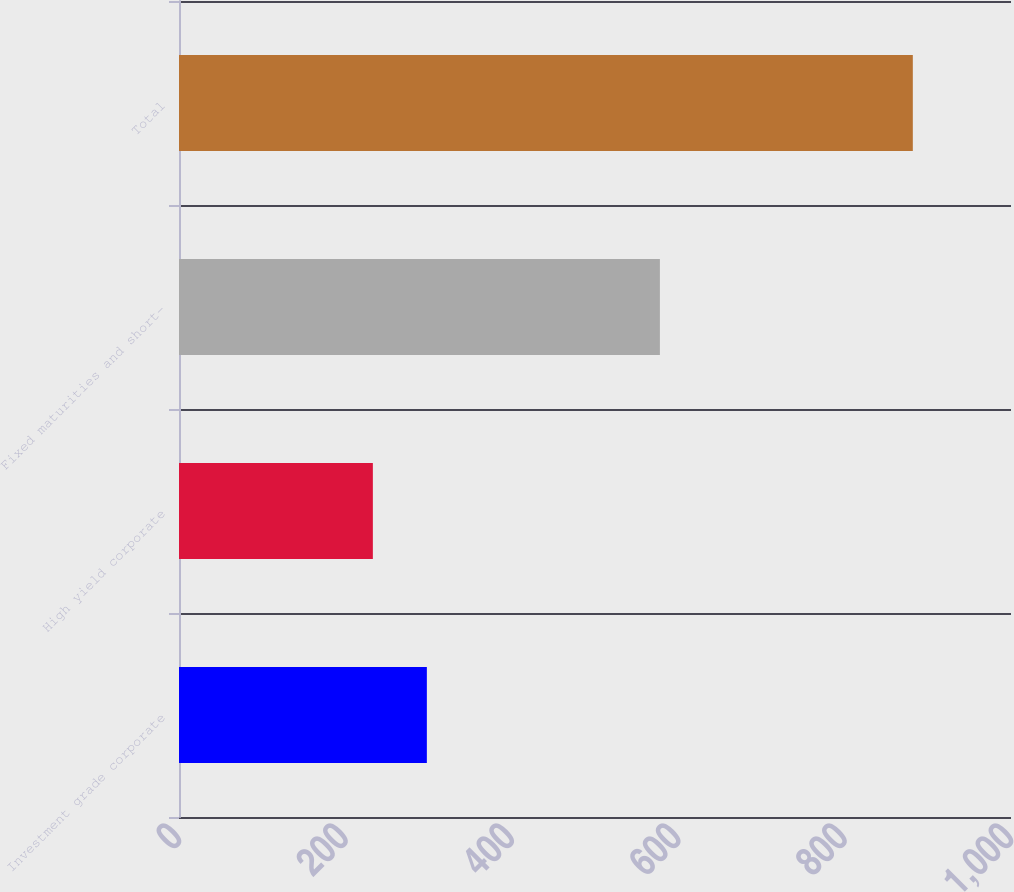Convert chart. <chart><loc_0><loc_0><loc_500><loc_500><bar_chart><fcel>Investment grade corporate<fcel>High yield corporate<fcel>Fixed maturities and short-<fcel>Total<nl><fcel>297.9<fcel>233<fcel>578<fcel>882<nl></chart> 